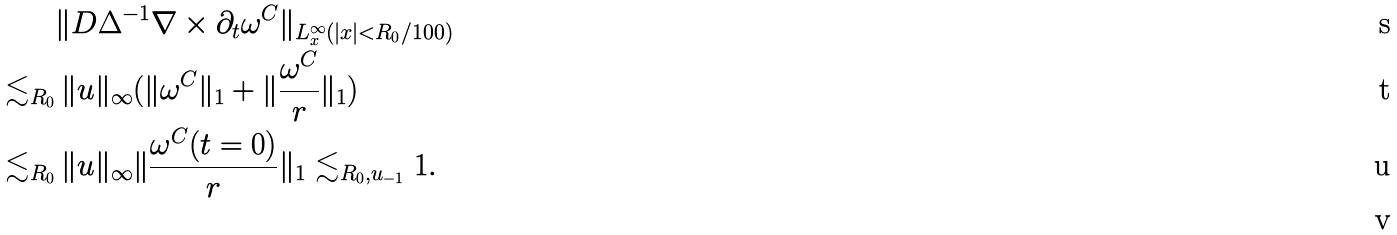Convert formula to latex. <formula><loc_0><loc_0><loc_500><loc_500>& \| D \Delta ^ { - 1 } \nabla \times \partial _ { t } \omega ^ { C } \| _ { L _ { x } ^ { \infty } ( | x | < R _ { 0 } / 1 0 0 ) } \\ \lesssim _ { R _ { 0 } } & \, \| u \| _ { \infty } ( \| \omega ^ { C } \| _ { 1 } + \| \frac { \omega ^ { C } } r \| _ { 1 } ) \\ \lesssim _ { R _ { 0 } } & \, \| u \| _ { \infty } \| \frac { \omega ^ { C } ( t = 0 ) } r \| _ { 1 } \lesssim _ { R _ { 0 } , u _ { - 1 } } 1 . \\</formula> 